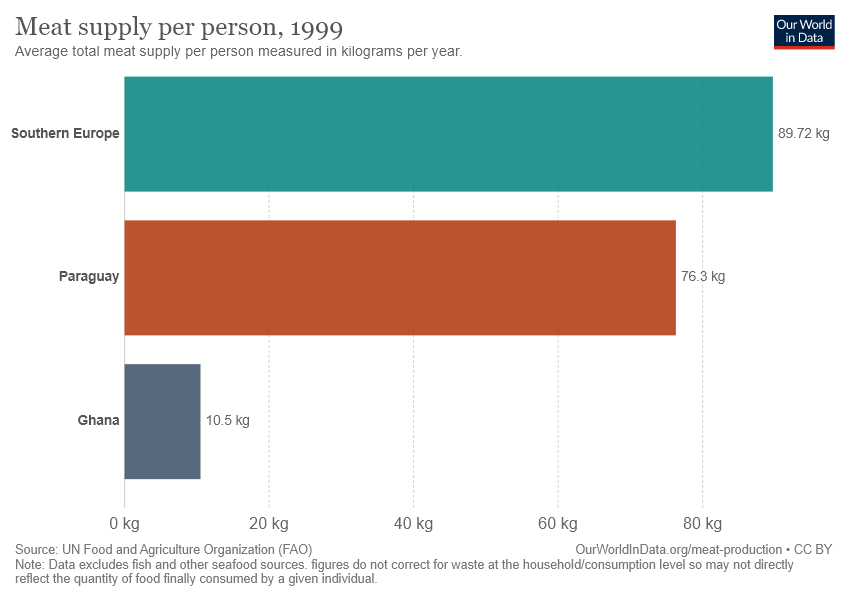How does Ghana's meat supply compare to other regions shown? The image displays a bar chart where Ghana's meat supply is significantly lower than that of Southern Europe and Paraguay. Ghana is shown to have a supply of 10.5 kg per person, while Southern Europe and Paraguay have supplies of 89.72 kg and 76.3 kg per person, respectively, highlighting a stark contrast in meat consumption. 